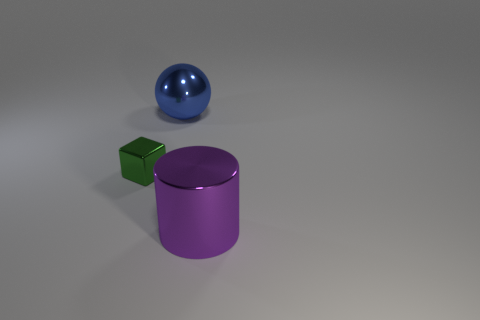Are there more metal things than small green blocks?
Offer a very short reply. Yes. What number of things are either big things behind the purple metal thing or green matte balls?
Your response must be concise. 1. Does the large sphere have the same material as the cylinder?
Provide a short and direct response. Yes. Do the large metal thing that is to the left of the cylinder and the large object in front of the small green object have the same shape?
Keep it short and to the point. No. Is the size of the shiny cylinder the same as the thing behind the cube?
Offer a very short reply. Yes. What number of other objects are there of the same material as the big purple thing?
Make the answer very short. 2. Is there anything else that is the same shape as the big purple shiny thing?
Your answer should be compact. No. What is the color of the thing right of the big object to the left of the metallic thing in front of the green block?
Your response must be concise. Purple. What shape is the metallic thing that is both in front of the blue sphere and to the right of the small block?
Your response must be concise. Cylinder. Is there any other thing that has the same size as the purple thing?
Offer a terse response. Yes. 